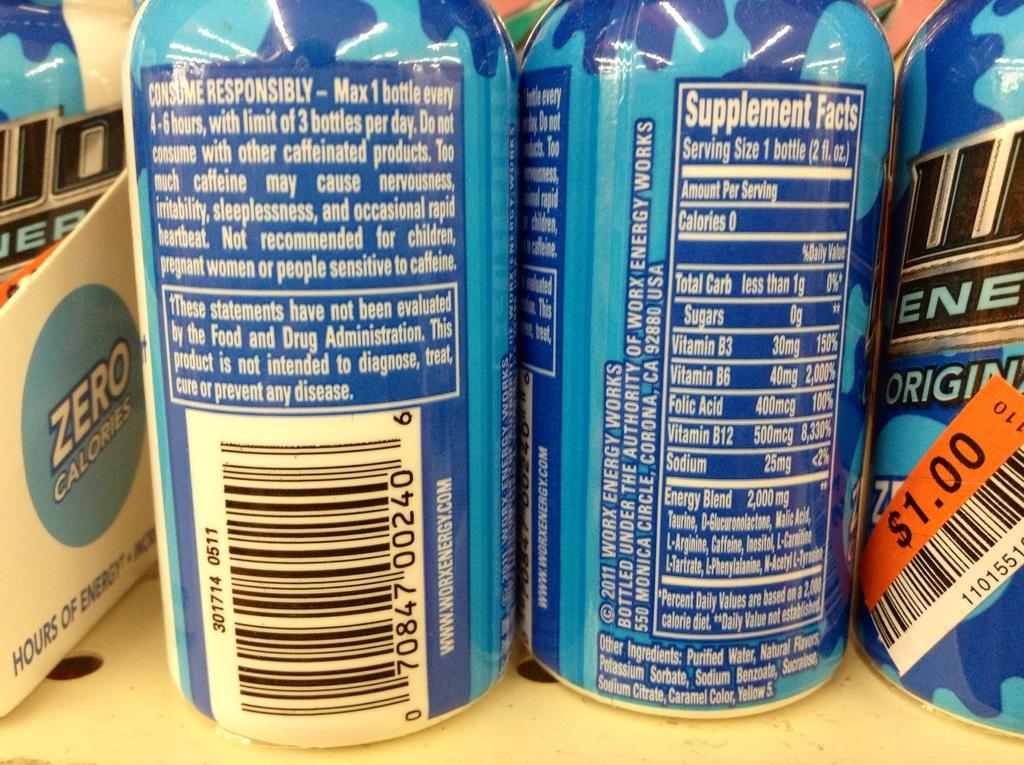<image>
Render a clear and concise summary of the photo. Beer can with the words "Consume Repsonsibly" on the back. 